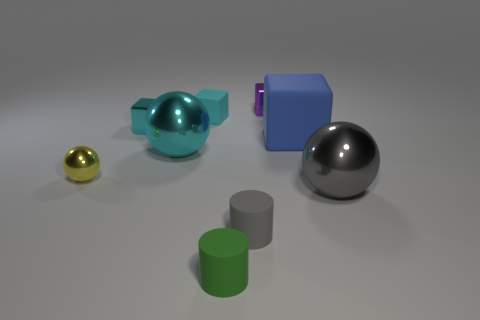Subtract all brown cubes. Subtract all blue balls. How many cubes are left? 4 Subtract all balls. How many objects are left? 6 Subtract 0 purple cylinders. How many objects are left? 9 Subtract all tiny purple metallic blocks. Subtract all green cylinders. How many objects are left? 7 Add 3 large cyan balls. How many large cyan balls are left? 4 Add 4 big cylinders. How many big cylinders exist? 4 